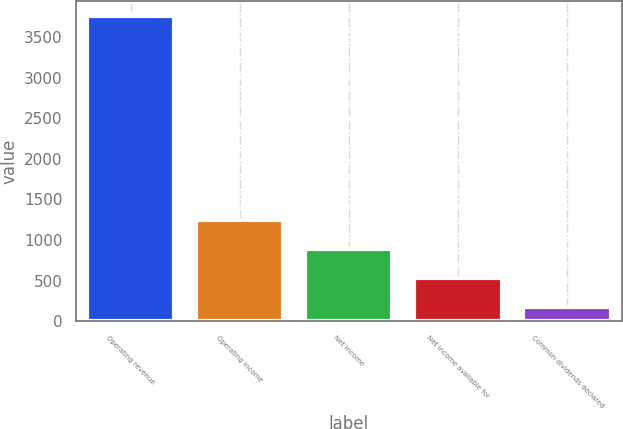Convert chart. <chart><loc_0><loc_0><loc_500><loc_500><bar_chart><fcel>Operating revenue<fcel>Operating income<fcel>Net income<fcel>Net income available for<fcel>Common dividends declared<nl><fcel>3752<fcel>1244.6<fcel>886.4<fcel>528.2<fcel>170<nl></chart> 